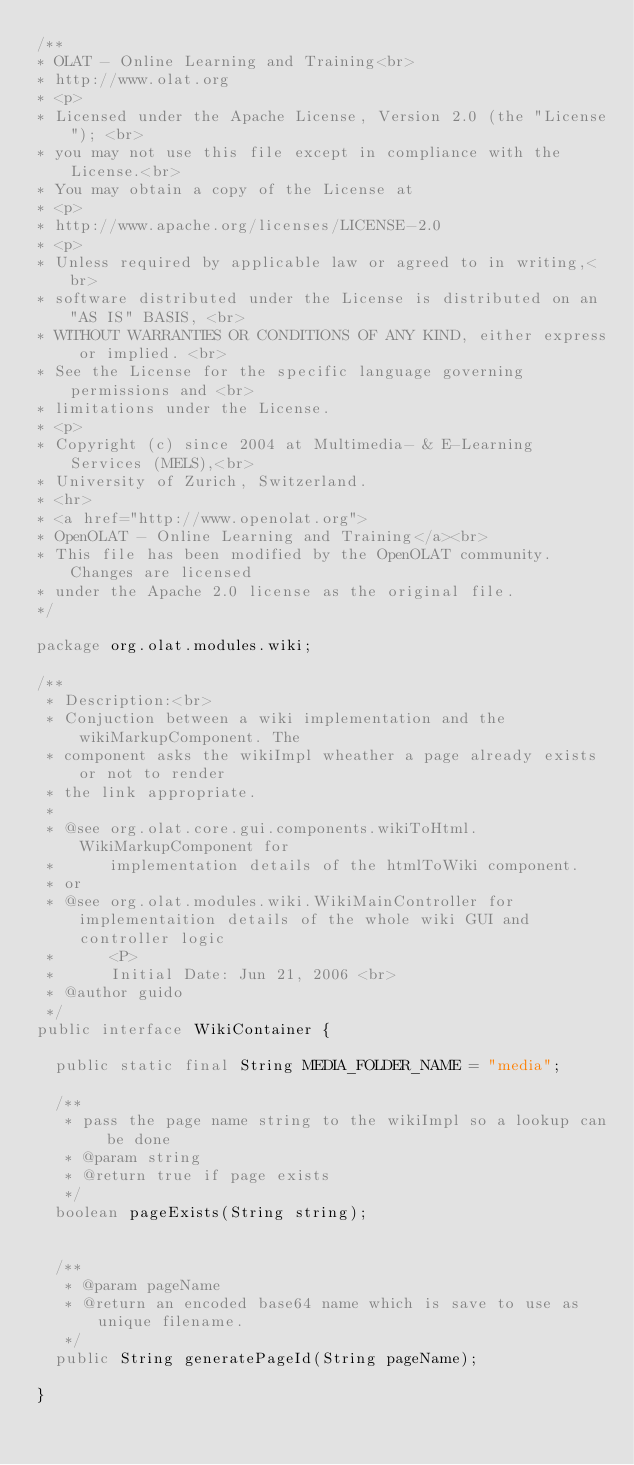<code> <loc_0><loc_0><loc_500><loc_500><_Java_>/**
* OLAT - Online Learning and Training<br>
* http://www.olat.org
* <p>
* Licensed under the Apache License, Version 2.0 (the "License"); <br>
* you may not use this file except in compliance with the License.<br>
* You may obtain a copy of the License at
* <p>
* http://www.apache.org/licenses/LICENSE-2.0
* <p>
* Unless required by applicable law or agreed to in writing,<br>
* software distributed under the License is distributed on an "AS IS" BASIS, <br>
* WITHOUT WARRANTIES OR CONDITIONS OF ANY KIND, either express or implied. <br>
* See the License for the specific language governing permissions and <br>
* limitations under the License.
* <p>
* Copyright (c) since 2004 at Multimedia- & E-Learning Services (MELS),<br>
* University of Zurich, Switzerland.
* <hr>
* <a href="http://www.openolat.org">
* OpenOLAT - Online Learning and Training</a><br>
* This file has been modified by the OpenOLAT community. Changes are licensed
* under the Apache 2.0 license as the original file.
*/

package org.olat.modules.wiki;

/**
 * Description:<br>
 * Conjuction between a wiki implementation and the wikiMarkupComponent. The
 * component asks the wikiImpl wheather a page already exists or not to render
 * the link appropriate.
 * 
 * @see org.olat.core.gui.components.wikiToHtml.WikiMarkupComponent for
 *      implementation details of the htmlToWiki component.
 * or
 * @see org.olat.modules.wiki.WikiMainController for implementaition details of the whole wiki GUI and controller logic
 *      <P>
 *      Initial Date: Jun 21, 2006 <br>
 * @author guido
 */
public interface WikiContainer {

	public static final String MEDIA_FOLDER_NAME = "media";

	/**
	 * pass the page name string to the wikiImpl so a lookup can be done
	 * @param string
	 * @return true if page exists
	 */
	boolean pageExists(String string);
	

	/**
	 * @param pageName
	 * @return an encoded base64 name which is save to use as unique filename.
	 */
	public String generatePageId(String pageName);

}
</code> 